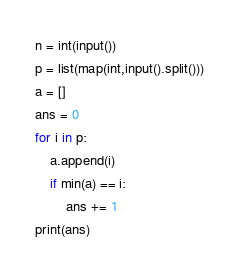<code> <loc_0><loc_0><loc_500><loc_500><_Python_>n = int(input())
p = list(map(int,input().split()))
a = []
ans = 0
for i in p:
    a.append(i)
    if min(a) == i:
        ans += 1
print(ans)</code> 